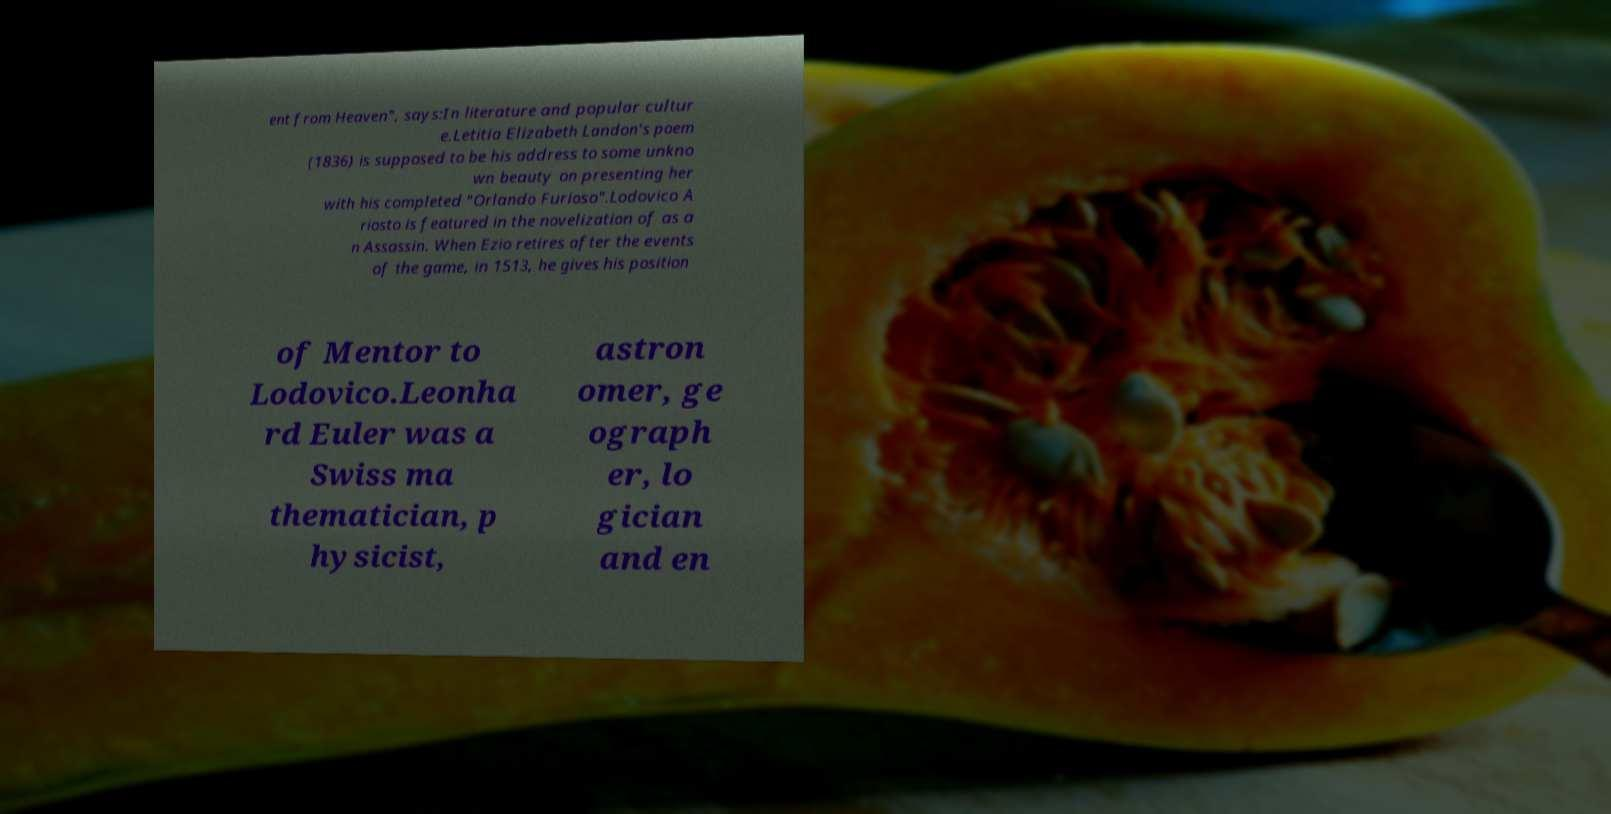Could you assist in decoding the text presented in this image and type it out clearly? ent from Heaven", says:In literature and popular cultur e.Letitia Elizabeth Landon's poem (1836) is supposed to be his address to some unkno wn beauty on presenting her with his completed "Orlando Furioso".Lodovico A riosto is featured in the novelization of as a n Assassin. When Ezio retires after the events of the game, in 1513, he gives his position of Mentor to Lodovico.Leonha rd Euler was a Swiss ma thematician, p hysicist, astron omer, ge ograph er, lo gician and en 